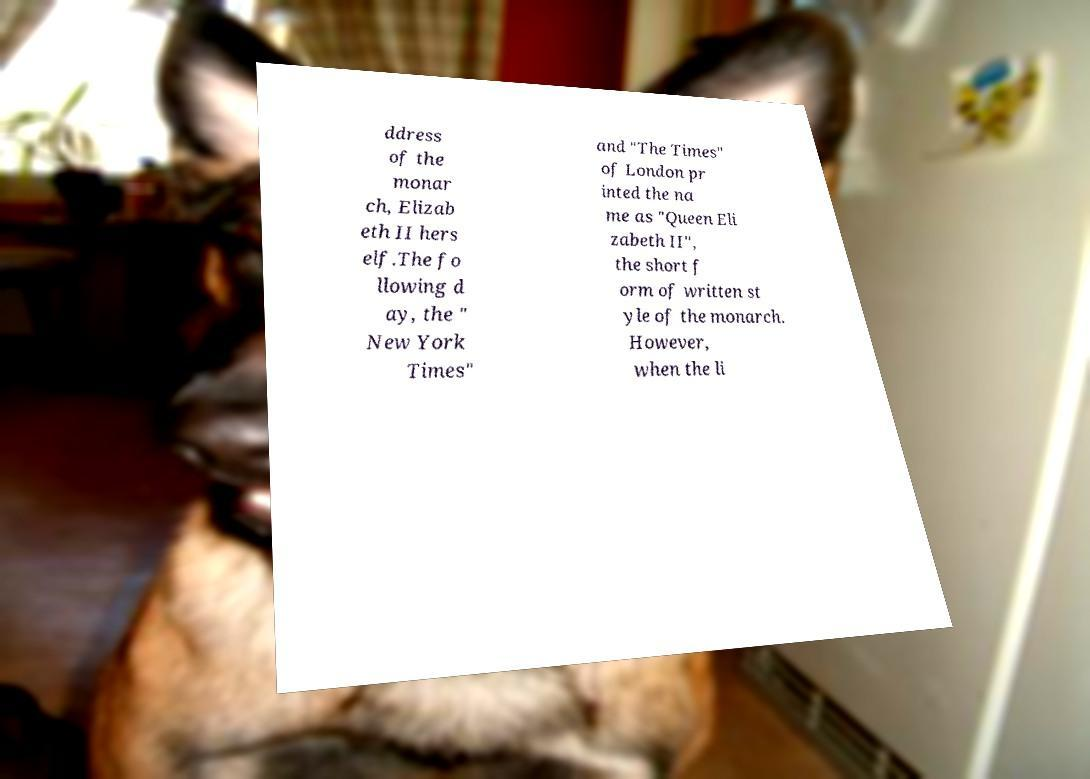There's text embedded in this image that I need extracted. Can you transcribe it verbatim? ddress of the monar ch, Elizab eth II hers elf.The fo llowing d ay, the " New York Times" and "The Times" of London pr inted the na me as "Queen Eli zabeth II", the short f orm of written st yle of the monarch. However, when the li 